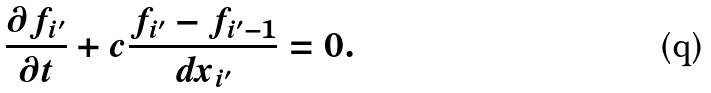<formula> <loc_0><loc_0><loc_500><loc_500>\frac { \partial f _ { i ^ { \prime } } } { \partial t } + c \frac { f _ { i ^ { \prime } } - f _ { i ^ { \prime } - 1 } } { d x _ { i ^ { \prime } } } = 0 .</formula> 